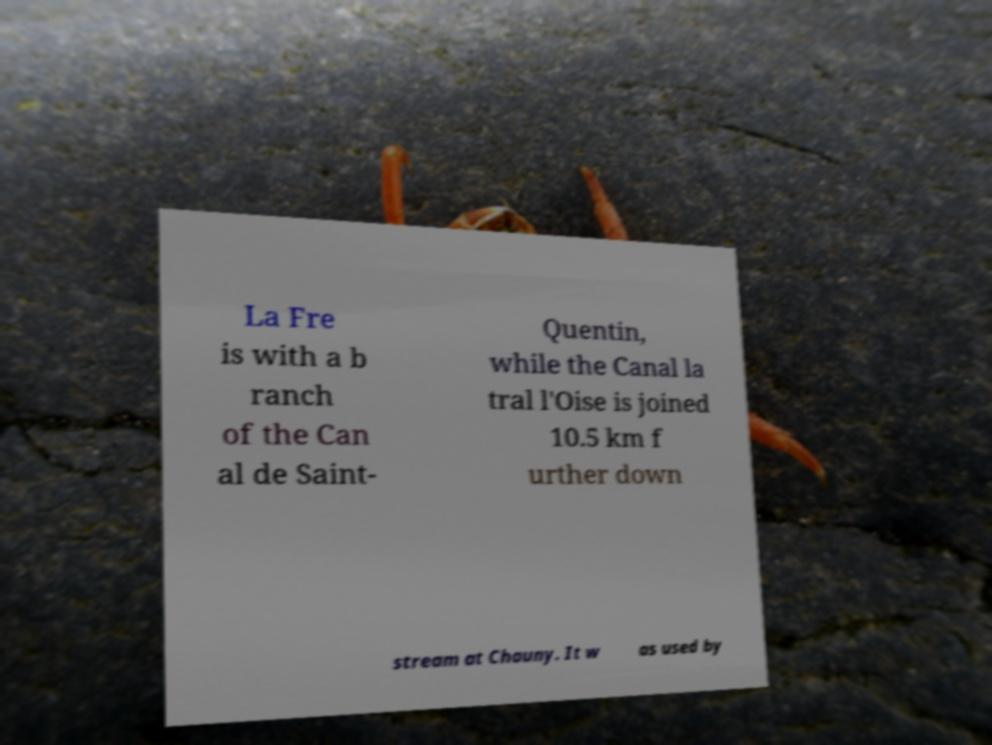Please identify and transcribe the text found in this image. La Fre is with a b ranch of the Can al de Saint- Quentin, while the Canal la tral l'Oise is joined 10.5 km f urther down stream at Chauny. It w as used by 